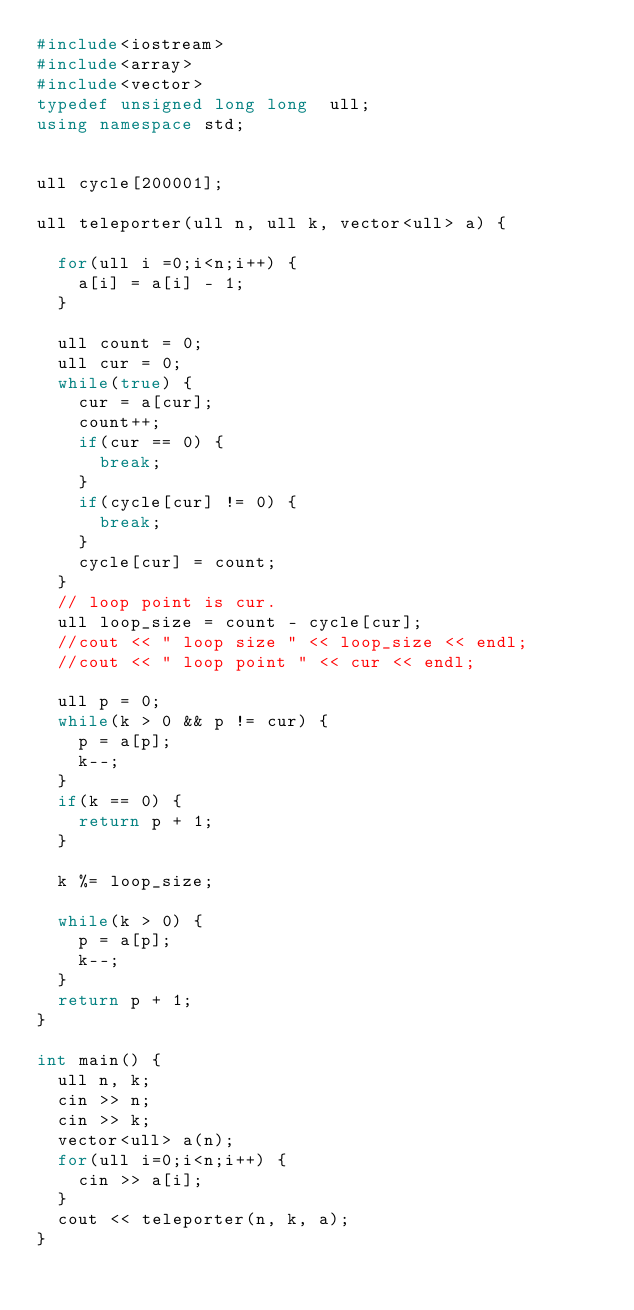Convert code to text. <code><loc_0><loc_0><loc_500><loc_500><_C++_>#include<iostream>
#include<array>
#include<vector>
typedef unsigned long long  ull;
using namespace std;


ull cycle[200001];

ull teleporter(ull n, ull k, vector<ull> a) {

  for(ull i =0;i<n;i++) {
    a[i] = a[i] - 1;
  }

  ull count = 0;
  ull cur = 0;
  while(true) {
    cur = a[cur];
    count++;
    if(cur == 0) {
      break;
    }
    if(cycle[cur] != 0) {
      break;
    }
    cycle[cur] = count;
  }
  // loop point is cur.
  ull loop_size = count - cycle[cur];
  //cout << " loop size " << loop_size << endl;
  //cout << " loop point " << cur << endl;

  ull p = 0;
  while(k > 0 && p != cur) {
    p = a[p];
    k--;
  }
  if(k == 0) {
    return p + 1;
  }

  k %= loop_size;

  while(k > 0) {
    p = a[p];
    k--;
  }
  return p + 1;
}

int main() {
  ull n, k;
  cin >> n;
  cin >> k;
  vector<ull> a(n);
  for(ull i=0;i<n;i++) {
    cin >> a[i];
  }
  cout << teleporter(n, k, a);
}</code> 